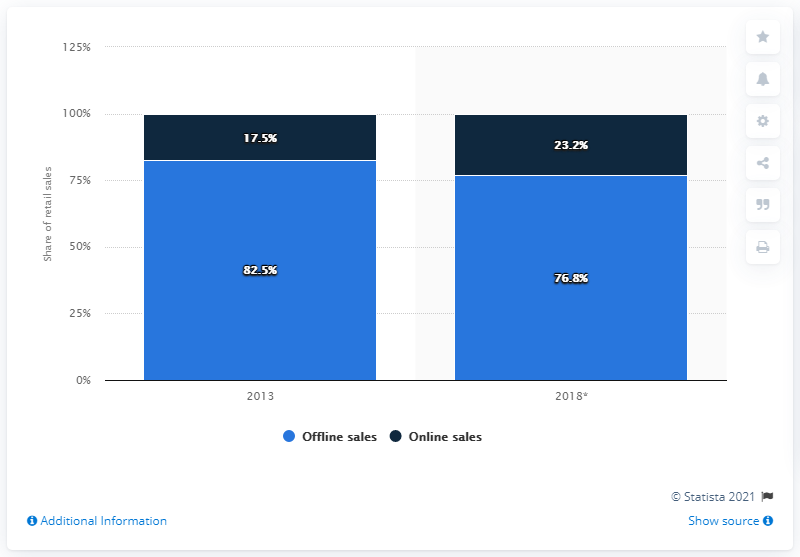What additional information might we need to fully understand the market dynamics for electricals and electronics in Germany? To gain a complete picture of the market dynamics, we would need data on total sales volume, the absolute growth of both online and offline channels, customer buying behavior changes, and how these figures compare with overall economic trends in Germany. 